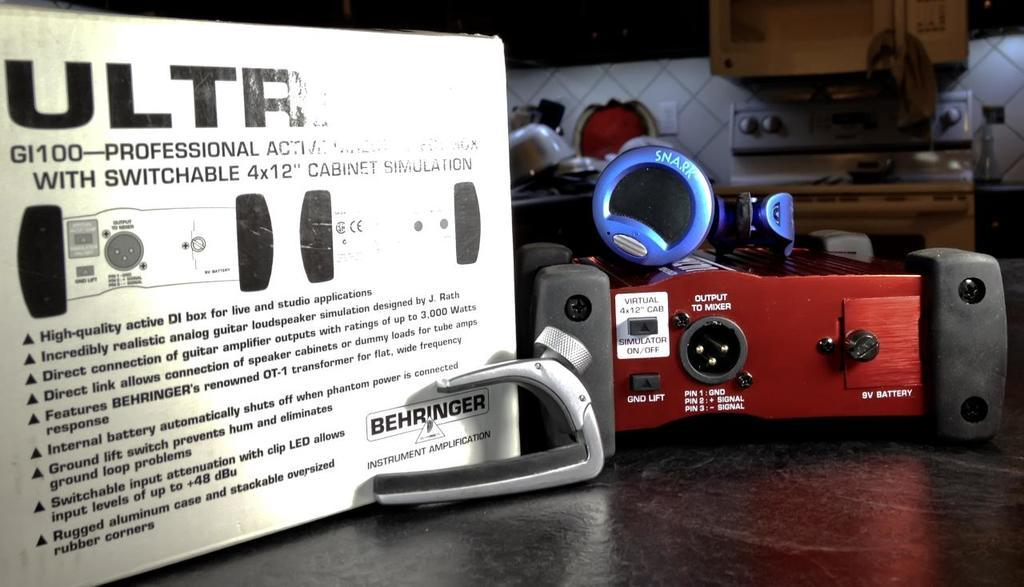<image>
Offer a succinct explanation of the picture presented. Musical equipment on a table including an instrument amplifier by Behringer. 